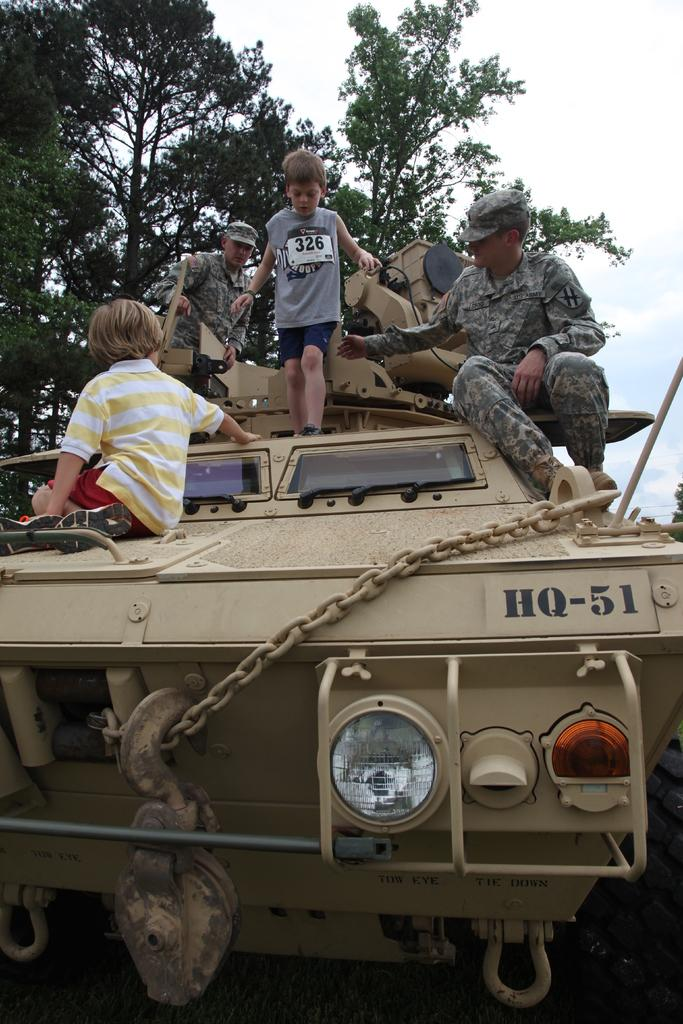What are the people in the image doing? The people in the image are sitting on a vehicle. What is the child in the image doing? The child is standing on the vehicle. What can be seen in the background of the image? There are trees and the sky visible in the background of the image. How would you describe the sky in the image? The sky appears to be cloudy in the image. What type of crayon is the child using to draw on the vehicle? There is no crayon present in the image, and the child is not drawing on the vehicle. 